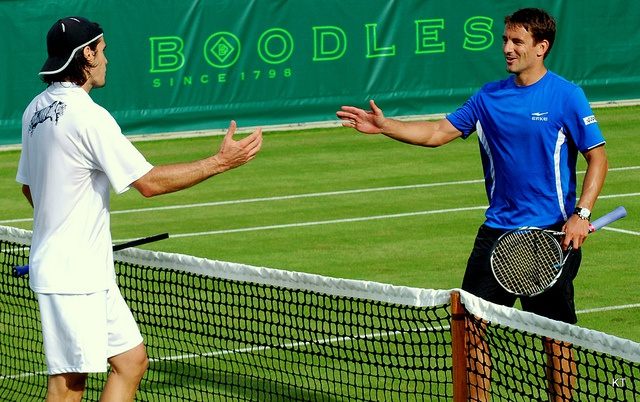Describe the objects in this image and their specific colors. I can see people in darkgreen, ivory, black, darkgray, and tan tones, people in darkgreen, black, blue, darkblue, and navy tones, tennis racket in darkgreen, black, gray, and olive tones, and tennis racket in darkgreen, black, teal, and darkgray tones in this image. 